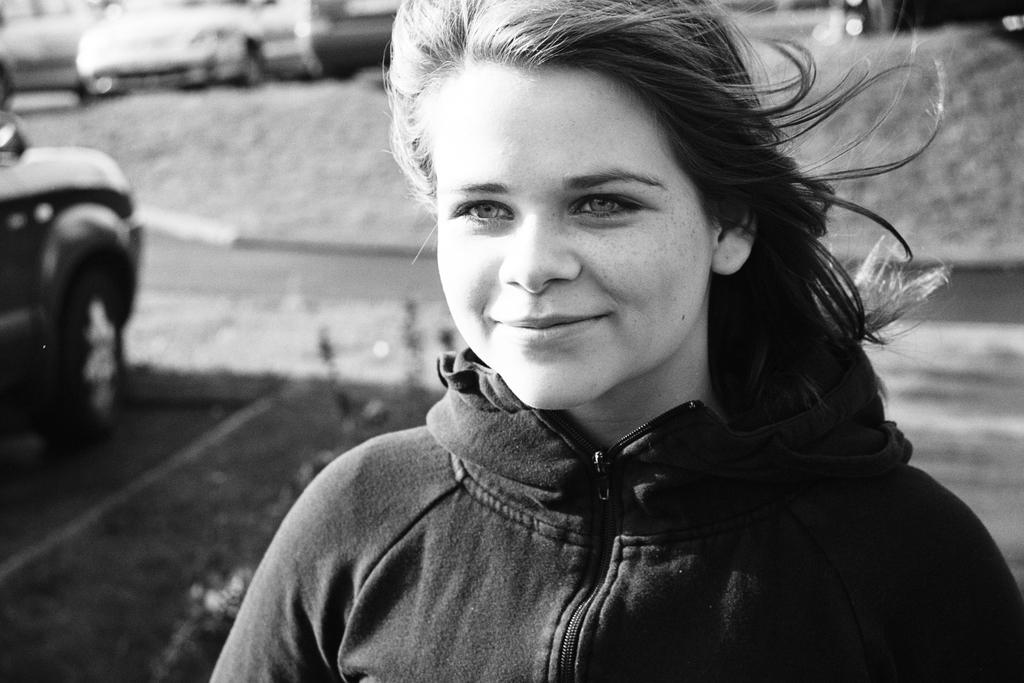Who is the main subject in the image? There is a girl in the image. What is the girl wearing? The girl is wearing a black jacket. What is the girl doing in the image? The girl is standing and smiling. What can be seen in the background of the image? There are parked cars visible in the background of the image. What action does the guide perform in the image? There is no guide present in the image, so no action can be attributed to a guide. 